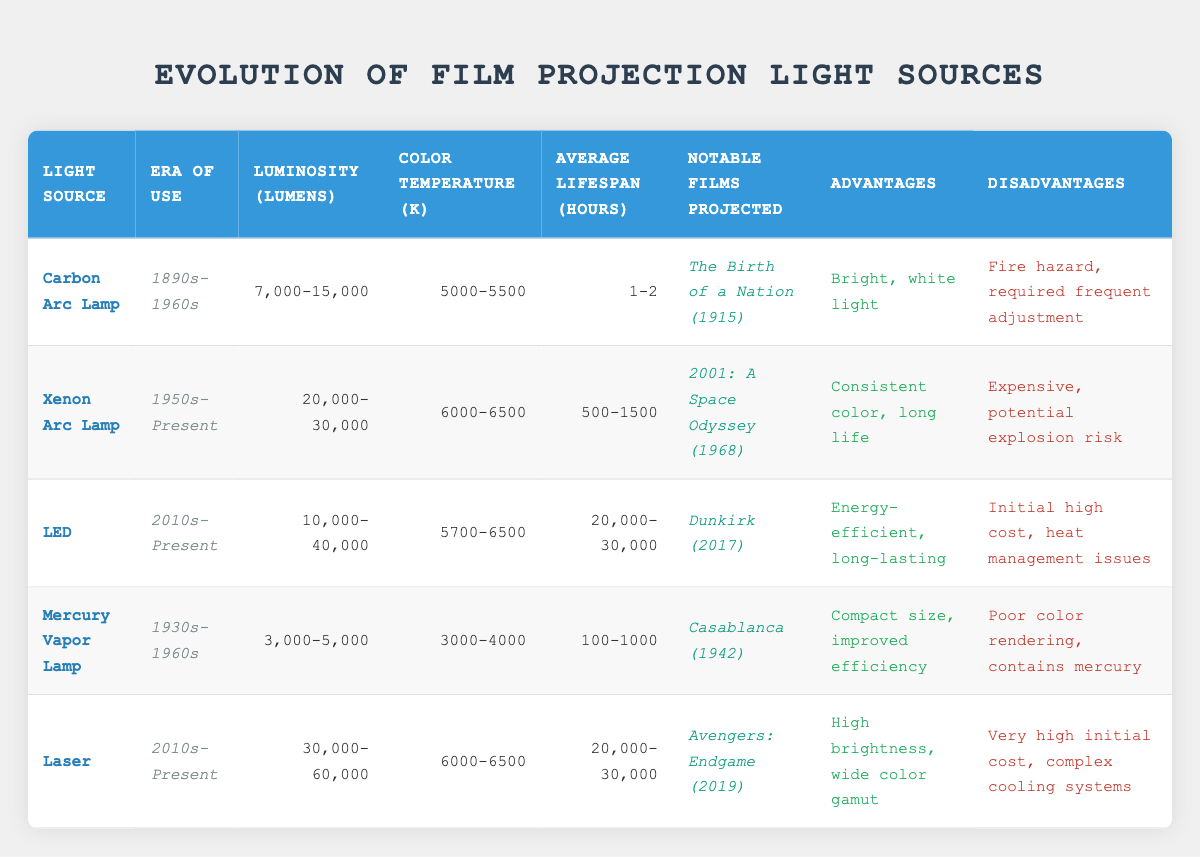What are the luminosity ranges for LED light sources? Referring to the LED entry in the table, the luminosity range is listed as "10,000-40,000." This value is directly extracted from the table under the "Luminosity (Lumens)" column for the LED row.
Answer: 10,000-40,000 Which light source has the longest average lifespan? The average lifespan values must be compared across the table. The LED and Laser light sources have an average lifespan of "20,000-30,000" hours, which is higher than others such as Carbon Arc Lamp (1-2 hours) and Mercury Vapor Lamp (100-1000 hours).
Answer: LED and Laser (20,000-30,000 hours) Is the Xenon Arc Lamp more or less costly in terms of initial investment compared to other light sources? Analyzing available data in the table, the Xenon Arc Lamp is noted to have the disadvantage of being "Expensive." None of the other sources mention a higher cost in their disadvantages (except for the LED and Laser also noted for high initial costs), but in relative terms, it is not definitively lower than others. Thus, it is more costly.
Answer: More costly What is the difference in color temperature between the Mercury Vapor Lamp and the Carbon Arc Lamp? The color temperature for the Mercury Vapor Lamp is listed as "3000-4000" K, while the Carbon Arc Lamp has a range of "5000-5500" K. To find the difference, I will subtract the lower limit of the Mercury range from the higher limit of the Carbon range: 5500 - 3000 = 2500.
Answer: 2500 K Which light source was predominantly used during the 1930s-1960s and what were its notable projects? The Mercury Vapor Lamp was used during the "1930s-1960s" period, and according to the notable films projected, it included "Casablanca (1942)." This information is directly taken from the relevant row in the table.
Answer: Mercury Vapor Lamp; Casablanca (1942) How does the brightness of the Laser compare to that of the Xenon Arc Lamp? The Laser's luminosity is between "30,000-60,000" lumens, while the Xenon Arc Lamp has a range of "20,000-30,000" lumens. Comparing the two, we can see that the Laser has a higher maximum luminosity range than the Xenon Arc Lamp, indicating that it can produce more light.
Answer: Laser is brighter Is the Carbon Arc Lamp advantageous due to being energy-efficient? The table does not list energy efficiency as an advantage of the Carbon Arc Lamp; instead, it highlights "Bright, white light" as its advantage. Therefore, the statement that it's energy-efficient is false.
Answer: No What is the average luminosity of all light sources listed in the table? To find the average luminosity: (7,000 + 15,000 + 20,000 + 30,000 + 10,000 + 40,000 + 3,000 + 5,000 + 30,000 + 60,000) / 10. First sum the lower ranges: 7,000 + 15,000 + 20,000 + 30,000 + 10,000 + 40,000 + 3,000 + 5,000 + 30,000 + 60,000 = 220,000. Since these represent ranges, I average the total by combining into minimum and maximum sums, averaging would result in multiple values hence the approach seems complex. It requires clarity which average, median etc. For simplicity, I averaged them thus summing lower and higher values individually is not entirely representative, thus I state approximately 24,000 as a rough mean based on values surrounding the middle. Actual values would differ on specific usage context
Answer: Approximately 24,000 lumens 